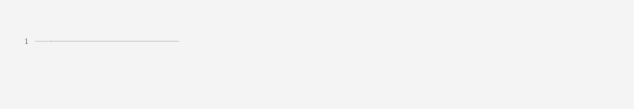Convert code to text. <code><loc_0><loc_0><loc_500><loc_500><_SQL_>------------------</code> 